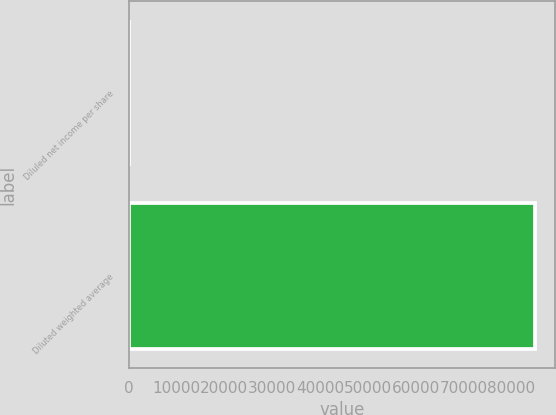Convert chart to OTSL. <chart><loc_0><loc_0><loc_500><loc_500><bar_chart><fcel>Diluled net income per share<fcel>Diluted weighted average<nl><fcel>1.34<fcel>84830<nl></chart> 